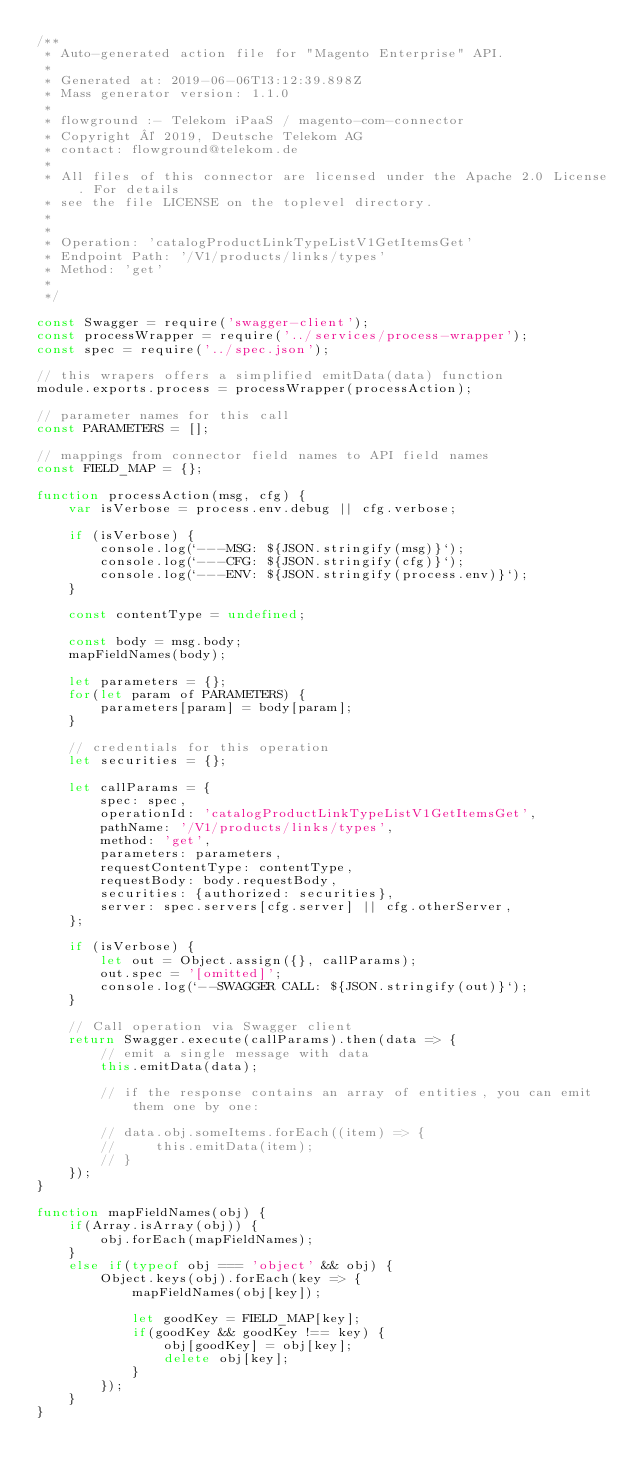Convert code to text. <code><loc_0><loc_0><loc_500><loc_500><_JavaScript_>/**
 * Auto-generated action file for "Magento Enterprise" API.
 *
 * Generated at: 2019-06-06T13:12:39.898Z
 * Mass generator version: 1.1.0
 *
 * flowground :- Telekom iPaaS / magento-com-connector
 * Copyright © 2019, Deutsche Telekom AG
 * contact: flowground@telekom.de
 *
 * All files of this connector are licensed under the Apache 2.0 License. For details
 * see the file LICENSE on the toplevel directory.
 *
 *
 * Operation: 'catalogProductLinkTypeListV1GetItemsGet'
 * Endpoint Path: '/V1/products/links/types'
 * Method: 'get'
 *
 */

const Swagger = require('swagger-client');
const processWrapper = require('../services/process-wrapper');
const spec = require('../spec.json');

// this wrapers offers a simplified emitData(data) function
module.exports.process = processWrapper(processAction);

// parameter names for this call
const PARAMETERS = [];

// mappings from connector field names to API field names
const FIELD_MAP = {};

function processAction(msg, cfg) {
    var isVerbose = process.env.debug || cfg.verbose;

    if (isVerbose) {
        console.log(`---MSG: ${JSON.stringify(msg)}`);
        console.log(`---CFG: ${JSON.stringify(cfg)}`);
        console.log(`---ENV: ${JSON.stringify(process.env)}`);
    }

    const contentType = undefined;

    const body = msg.body;
    mapFieldNames(body);

    let parameters = {};
    for(let param of PARAMETERS) {
        parameters[param] = body[param];
    }

    // credentials for this operation
    let securities = {};

    let callParams = {
        spec: spec,
        operationId: 'catalogProductLinkTypeListV1GetItemsGet',
        pathName: '/V1/products/links/types',
        method: 'get',
        parameters: parameters,
        requestContentType: contentType,
        requestBody: body.requestBody,
        securities: {authorized: securities},
        server: spec.servers[cfg.server] || cfg.otherServer,
    };

    if (isVerbose) {
        let out = Object.assign({}, callParams);
        out.spec = '[omitted]';
        console.log(`--SWAGGER CALL: ${JSON.stringify(out)}`);
    }

    // Call operation via Swagger client
    return Swagger.execute(callParams).then(data => {
        // emit a single message with data
        this.emitData(data);

        // if the response contains an array of entities, you can emit them one by one:

        // data.obj.someItems.forEach((item) => {
        //     this.emitData(item);
        // }
    });
}

function mapFieldNames(obj) {
    if(Array.isArray(obj)) {
        obj.forEach(mapFieldNames);
    }
    else if(typeof obj === 'object' && obj) {
        Object.keys(obj).forEach(key => {
            mapFieldNames(obj[key]);

            let goodKey = FIELD_MAP[key];
            if(goodKey && goodKey !== key) {
                obj[goodKey] = obj[key];
                delete obj[key];
            }
        });
    }
}</code> 